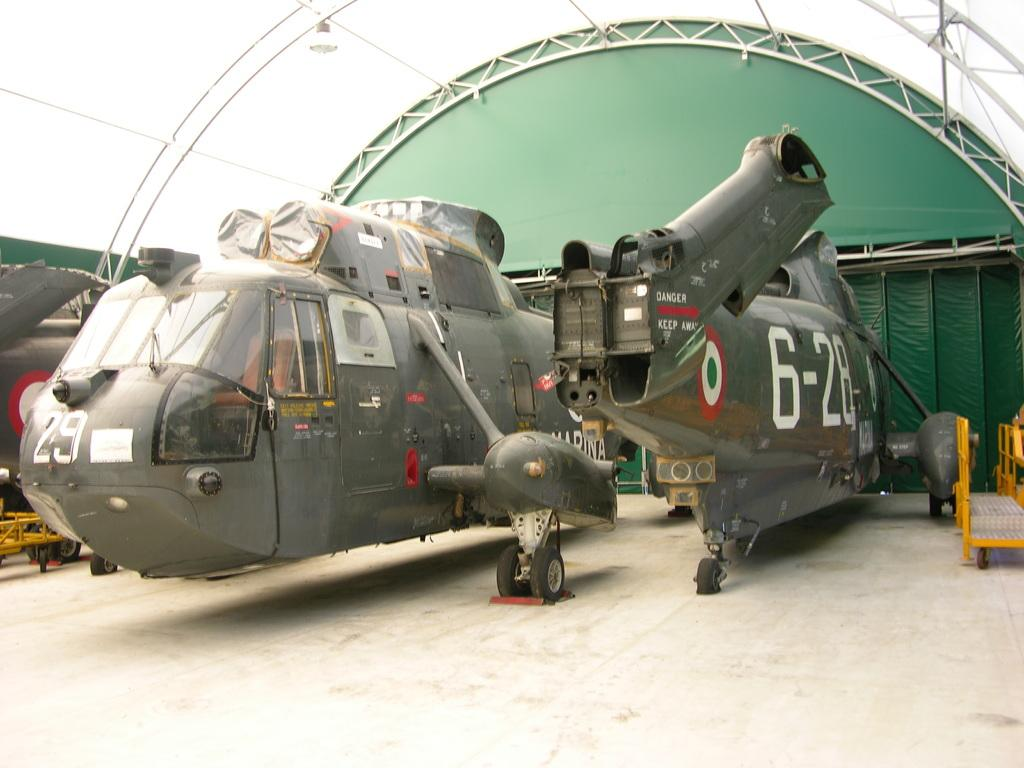<image>
Offer a succinct explanation of the picture presented. Several large helicopters in a hanger, they warn Danger Keep away on the side. 